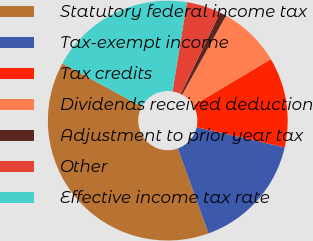Convert chart. <chart><loc_0><loc_0><loc_500><loc_500><pie_chart><fcel>Statutory federal income tax<fcel>Tax-exempt income<fcel>Tax credits<fcel>Dividends received deduction<fcel>Adjustment to prior year tax<fcel>Other<fcel>Effective income tax rate<nl><fcel>38.42%<fcel>15.89%<fcel>12.14%<fcel>8.39%<fcel>0.88%<fcel>4.63%<fcel>19.65%<nl></chart> 